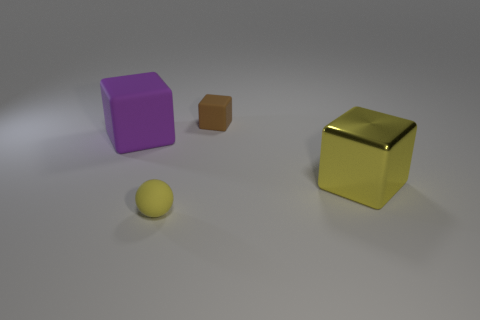Add 4 large metallic blocks. How many objects exist? 8 Subtract all spheres. How many objects are left? 3 Subtract 0 purple cylinders. How many objects are left? 4 Subtract all large matte things. Subtract all yellow matte things. How many objects are left? 2 Add 3 blocks. How many blocks are left? 6 Add 3 big yellow metal objects. How many big yellow metal objects exist? 4 